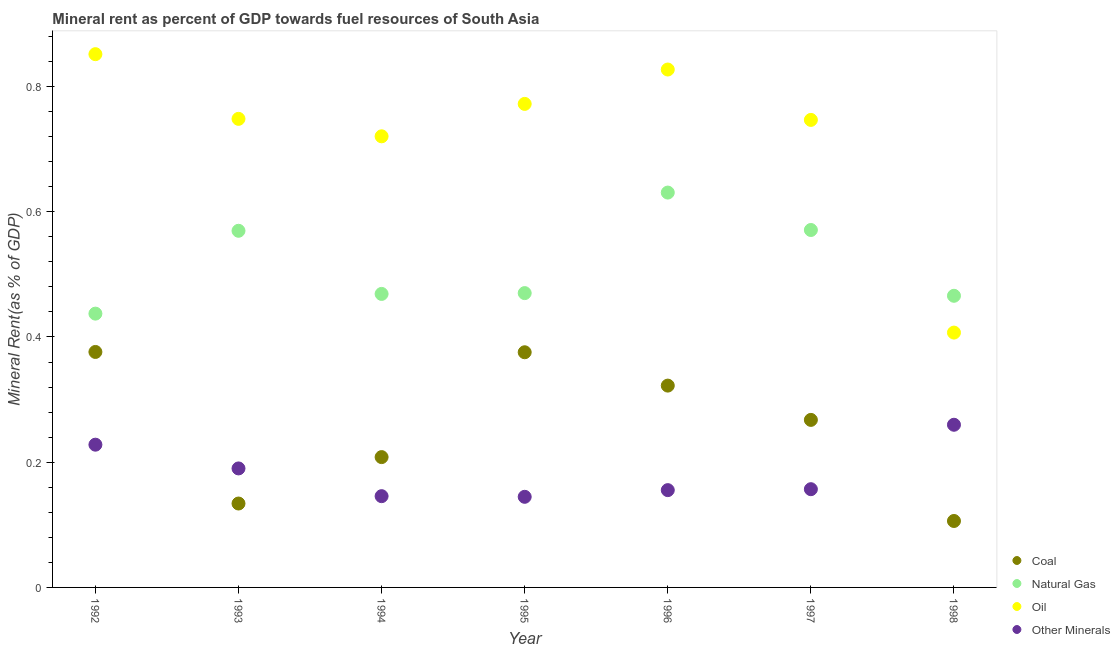What is the  rent of other minerals in 1996?
Ensure brevity in your answer.  0.16. Across all years, what is the maximum  rent of other minerals?
Provide a short and direct response. 0.26. Across all years, what is the minimum oil rent?
Your response must be concise. 0.41. In which year was the  rent of other minerals minimum?
Give a very brief answer. 1995. What is the total natural gas rent in the graph?
Offer a very short reply. 3.61. What is the difference between the coal rent in 1994 and that in 1996?
Offer a terse response. -0.11. What is the difference between the oil rent in 1994 and the coal rent in 1995?
Keep it short and to the point. 0.34. What is the average natural gas rent per year?
Give a very brief answer. 0.52. In the year 1992, what is the difference between the natural gas rent and  rent of other minerals?
Give a very brief answer. 0.21. In how many years, is the  rent of other minerals greater than 0.7600000000000001 %?
Give a very brief answer. 0. What is the ratio of the coal rent in 1993 to that in 1994?
Give a very brief answer. 0.64. Is the oil rent in 1997 less than that in 1998?
Keep it short and to the point. No. What is the difference between the highest and the second highest natural gas rent?
Provide a short and direct response. 0.06. What is the difference between the highest and the lowest  rent of other minerals?
Make the answer very short. 0.12. In how many years, is the coal rent greater than the average coal rent taken over all years?
Provide a short and direct response. 4. Is it the case that in every year, the sum of the coal rent and natural gas rent is greater than the oil rent?
Your response must be concise. No. How many years are there in the graph?
Your answer should be compact. 7. What is the difference between two consecutive major ticks on the Y-axis?
Your answer should be compact. 0.2. Does the graph contain grids?
Keep it short and to the point. No. How many legend labels are there?
Your answer should be very brief. 4. How are the legend labels stacked?
Keep it short and to the point. Vertical. What is the title of the graph?
Offer a very short reply. Mineral rent as percent of GDP towards fuel resources of South Asia. What is the label or title of the Y-axis?
Your answer should be compact. Mineral Rent(as % of GDP). What is the Mineral Rent(as % of GDP) of Coal in 1992?
Your answer should be compact. 0.38. What is the Mineral Rent(as % of GDP) of Natural Gas in 1992?
Make the answer very short. 0.44. What is the Mineral Rent(as % of GDP) in Oil in 1992?
Offer a very short reply. 0.85. What is the Mineral Rent(as % of GDP) of Other Minerals in 1992?
Ensure brevity in your answer.  0.23. What is the Mineral Rent(as % of GDP) in Coal in 1993?
Your response must be concise. 0.13. What is the Mineral Rent(as % of GDP) in Natural Gas in 1993?
Your response must be concise. 0.57. What is the Mineral Rent(as % of GDP) of Oil in 1993?
Keep it short and to the point. 0.75. What is the Mineral Rent(as % of GDP) in Other Minerals in 1993?
Provide a short and direct response. 0.19. What is the Mineral Rent(as % of GDP) of Coal in 1994?
Keep it short and to the point. 0.21. What is the Mineral Rent(as % of GDP) of Natural Gas in 1994?
Give a very brief answer. 0.47. What is the Mineral Rent(as % of GDP) of Oil in 1994?
Make the answer very short. 0.72. What is the Mineral Rent(as % of GDP) of Other Minerals in 1994?
Your response must be concise. 0.15. What is the Mineral Rent(as % of GDP) in Coal in 1995?
Your response must be concise. 0.38. What is the Mineral Rent(as % of GDP) of Natural Gas in 1995?
Make the answer very short. 0.47. What is the Mineral Rent(as % of GDP) of Oil in 1995?
Give a very brief answer. 0.77. What is the Mineral Rent(as % of GDP) in Other Minerals in 1995?
Make the answer very short. 0.14. What is the Mineral Rent(as % of GDP) of Coal in 1996?
Provide a succinct answer. 0.32. What is the Mineral Rent(as % of GDP) in Natural Gas in 1996?
Give a very brief answer. 0.63. What is the Mineral Rent(as % of GDP) of Oil in 1996?
Give a very brief answer. 0.83. What is the Mineral Rent(as % of GDP) in Other Minerals in 1996?
Provide a succinct answer. 0.16. What is the Mineral Rent(as % of GDP) in Coal in 1997?
Offer a terse response. 0.27. What is the Mineral Rent(as % of GDP) of Natural Gas in 1997?
Your response must be concise. 0.57. What is the Mineral Rent(as % of GDP) of Oil in 1997?
Keep it short and to the point. 0.75. What is the Mineral Rent(as % of GDP) of Other Minerals in 1997?
Your answer should be very brief. 0.16. What is the Mineral Rent(as % of GDP) in Coal in 1998?
Give a very brief answer. 0.11. What is the Mineral Rent(as % of GDP) in Natural Gas in 1998?
Provide a short and direct response. 0.47. What is the Mineral Rent(as % of GDP) in Oil in 1998?
Provide a succinct answer. 0.41. What is the Mineral Rent(as % of GDP) in Other Minerals in 1998?
Ensure brevity in your answer.  0.26. Across all years, what is the maximum Mineral Rent(as % of GDP) in Coal?
Provide a short and direct response. 0.38. Across all years, what is the maximum Mineral Rent(as % of GDP) in Natural Gas?
Provide a short and direct response. 0.63. Across all years, what is the maximum Mineral Rent(as % of GDP) in Oil?
Offer a very short reply. 0.85. Across all years, what is the maximum Mineral Rent(as % of GDP) in Other Minerals?
Your answer should be compact. 0.26. Across all years, what is the minimum Mineral Rent(as % of GDP) of Coal?
Your answer should be very brief. 0.11. Across all years, what is the minimum Mineral Rent(as % of GDP) in Natural Gas?
Keep it short and to the point. 0.44. Across all years, what is the minimum Mineral Rent(as % of GDP) of Oil?
Ensure brevity in your answer.  0.41. Across all years, what is the minimum Mineral Rent(as % of GDP) in Other Minerals?
Make the answer very short. 0.14. What is the total Mineral Rent(as % of GDP) in Coal in the graph?
Offer a terse response. 1.79. What is the total Mineral Rent(as % of GDP) of Natural Gas in the graph?
Your answer should be very brief. 3.61. What is the total Mineral Rent(as % of GDP) in Oil in the graph?
Provide a succinct answer. 5.07. What is the total Mineral Rent(as % of GDP) in Other Minerals in the graph?
Ensure brevity in your answer.  1.28. What is the difference between the Mineral Rent(as % of GDP) of Coal in 1992 and that in 1993?
Make the answer very short. 0.24. What is the difference between the Mineral Rent(as % of GDP) of Natural Gas in 1992 and that in 1993?
Your response must be concise. -0.13. What is the difference between the Mineral Rent(as % of GDP) in Oil in 1992 and that in 1993?
Give a very brief answer. 0.1. What is the difference between the Mineral Rent(as % of GDP) of Other Minerals in 1992 and that in 1993?
Your response must be concise. 0.04. What is the difference between the Mineral Rent(as % of GDP) in Coal in 1992 and that in 1994?
Your answer should be very brief. 0.17. What is the difference between the Mineral Rent(as % of GDP) of Natural Gas in 1992 and that in 1994?
Your answer should be very brief. -0.03. What is the difference between the Mineral Rent(as % of GDP) of Oil in 1992 and that in 1994?
Keep it short and to the point. 0.13. What is the difference between the Mineral Rent(as % of GDP) of Other Minerals in 1992 and that in 1994?
Provide a short and direct response. 0.08. What is the difference between the Mineral Rent(as % of GDP) in Coal in 1992 and that in 1995?
Offer a terse response. 0. What is the difference between the Mineral Rent(as % of GDP) in Natural Gas in 1992 and that in 1995?
Your answer should be very brief. -0.03. What is the difference between the Mineral Rent(as % of GDP) of Oil in 1992 and that in 1995?
Offer a very short reply. 0.08. What is the difference between the Mineral Rent(as % of GDP) of Other Minerals in 1992 and that in 1995?
Keep it short and to the point. 0.08. What is the difference between the Mineral Rent(as % of GDP) in Coal in 1992 and that in 1996?
Offer a terse response. 0.05. What is the difference between the Mineral Rent(as % of GDP) of Natural Gas in 1992 and that in 1996?
Offer a terse response. -0.19. What is the difference between the Mineral Rent(as % of GDP) in Oil in 1992 and that in 1996?
Offer a terse response. 0.02. What is the difference between the Mineral Rent(as % of GDP) in Other Minerals in 1992 and that in 1996?
Your response must be concise. 0.07. What is the difference between the Mineral Rent(as % of GDP) of Coal in 1992 and that in 1997?
Provide a short and direct response. 0.11. What is the difference between the Mineral Rent(as % of GDP) of Natural Gas in 1992 and that in 1997?
Provide a succinct answer. -0.13. What is the difference between the Mineral Rent(as % of GDP) of Oil in 1992 and that in 1997?
Provide a succinct answer. 0.1. What is the difference between the Mineral Rent(as % of GDP) of Other Minerals in 1992 and that in 1997?
Your response must be concise. 0.07. What is the difference between the Mineral Rent(as % of GDP) in Coal in 1992 and that in 1998?
Your answer should be very brief. 0.27. What is the difference between the Mineral Rent(as % of GDP) in Natural Gas in 1992 and that in 1998?
Provide a succinct answer. -0.03. What is the difference between the Mineral Rent(as % of GDP) of Oil in 1992 and that in 1998?
Keep it short and to the point. 0.44. What is the difference between the Mineral Rent(as % of GDP) in Other Minerals in 1992 and that in 1998?
Offer a very short reply. -0.03. What is the difference between the Mineral Rent(as % of GDP) in Coal in 1993 and that in 1994?
Your answer should be very brief. -0.07. What is the difference between the Mineral Rent(as % of GDP) in Natural Gas in 1993 and that in 1994?
Give a very brief answer. 0.1. What is the difference between the Mineral Rent(as % of GDP) of Oil in 1993 and that in 1994?
Offer a very short reply. 0.03. What is the difference between the Mineral Rent(as % of GDP) of Other Minerals in 1993 and that in 1994?
Give a very brief answer. 0.04. What is the difference between the Mineral Rent(as % of GDP) of Coal in 1993 and that in 1995?
Your answer should be very brief. -0.24. What is the difference between the Mineral Rent(as % of GDP) of Natural Gas in 1993 and that in 1995?
Offer a terse response. 0.1. What is the difference between the Mineral Rent(as % of GDP) in Oil in 1993 and that in 1995?
Offer a very short reply. -0.02. What is the difference between the Mineral Rent(as % of GDP) of Other Minerals in 1993 and that in 1995?
Offer a terse response. 0.05. What is the difference between the Mineral Rent(as % of GDP) of Coal in 1993 and that in 1996?
Provide a succinct answer. -0.19. What is the difference between the Mineral Rent(as % of GDP) of Natural Gas in 1993 and that in 1996?
Offer a terse response. -0.06. What is the difference between the Mineral Rent(as % of GDP) of Oil in 1993 and that in 1996?
Keep it short and to the point. -0.08. What is the difference between the Mineral Rent(as % of GDP) in Other Minerals in 1993 and that in 1996?
Keep it short and to the point. 0.03. What is the difference between the Mineral Rent(as % of GDP) in Coal in 1993 and that in 1997?
Provide a short and direct response. -0.13. What is the difference between the Mineral Rent(as % of GDP) of Natural Gas in 1993 and that in 1997?
Keep it short and to the point. -0. What is the difference between the Mineral Rent(as % of GDP) in Oil in 1993 and that in 1997?
Provide a succinct answer. 0. What is the difference between the Mineral Rent(as % of GDP) in Other Minerals in 1993 and that in 1997?
Offer a terse response. 0.03. What is the difference between the Mineral Rent(as % of GDP) of Coal in 1993 and that in 1998?
Your answer should be very brief. 0.03. What is the difference between the Mineral Rent(as % of GDP) of Natural Gas in 1993 and that in 1998?
Offer a terse response. 0.1. What is the difference between the Mineral Rent(as % of GDP) in Oil in 1993 and that in 1998?
Your answer should be compact. 0.34. What is the difference between the Mineral Rent(as % of GDP) of Other Minerals in 1993 and that in 1998?
Provide a short and direct response. -0.07. What is the difference between the Mineral Rent(as % of GDP) in Coal in 1994 and that in 1995?
Your answer should be very brief. -0.17. What is the difference between the Mineral Rent(as % of GDP) in Natural Gas in 1994 and that in 1995?
Ensure brevity in your answer.  -0. What is the difference between the Mineral Rent(as % of GDP) of Oil in 1994 and that in 1995?
Provide a short and direct response. -0.05. What is the difference between the Mineral Rent(as % of GDP) in Coal in 1994 and that in 1996?
Your answer should be very brief. -0.11. What is the difference between the Mineral Rent(as % of GDP) of Natural Gas in 1994 and that in 1996?
Ensure brevity in your answer.  -0.16. What is the difference between the Mineral Rent(as % of GDP) of Oil in 1994 and that in 1996?
Your answer should be very brief. -0.11. What is the difference between the Mineral Rent(as % of GDP) in Other Minerals in 1994 and that in 1996?
Your response must be concise. -0.01. What is the difference between the Mineral Rent(as % of GDP) in Coal in 1994 and that in 1997?
Make the answer very short. -0.06. What is the difference between the Mineral Rent(as % of GDP) of Natural Gas in 1994 and that in 1997?
Your answer should be compact. -0.1. What is the difference between the Mineral Rent(as % of GDP) of Oil in 1994 and that in 1997?
Provide a short and direct response. -0.03. What is the difference between the Mineral Rent(as % of GDP) in Other Minerals in 1994 and that in 1997?
Make the answer very short. -0.01. What is the difference between the Mineral Rent(as % of GDP) of Coal in 1994 and that in 1998?
Provide a short and direct response. 0.1. What is the difference between the Mineral Rent(as % of GDP) of Natural Gas in 1994 and that in 1998?
Give a very brief answer. 0. What is the difference between the Mineral Rent(as % of GDP) of Oil in 1994 and that in 1998?
Make the answer very short. 0.31. What is the difference between the Mineral Rent(as % of GDP) of Other Minerals in 1994 and that in 1998?
Offer a very short reply. -0.11. What is the difference between the Mineral Rent(as % of GDP) in Coal in 1995 and that in 1996?
Your answer should be very brief. 0.05. What is the difference between the Mineral Rent(as % of GDP) of Natural Gas in 1995 and that in 1996?
Give a very brief answer. -0.16. What is the difference between the Mineral Rent(as % of GDP) of Oil in 1995 and that in 1996?
Provide a short and direct response. -0.05. What is the difference between the Mineral Rent(as % of GDP) in Other Minerals in 1995 and that in 1996?
Offer a terse response. -0.01. What is the difference between the Mineral Rent(as % of GDP) of Coal in 1995 and that in 1997?
Make the answer very short. 0.11. What is the difference between the Mineral Rent(as % of GDP) of Natural Gas in 1995 and that in 1997?
Your response must be concise. -0.1. What is the difference between the Mineral Rent(as % of GDP) of Oil in 1995 and that in 1997?
Provide a short and direct response. 0.03. What is the difference between the Mineral Rent(as % of GDP) in Other Minerals in 1995 and that in 1997?
Make the answer very short. -0.01. What is the difference between the Mineral Rent(as % of GDP) in Coal in 1995 and that in 1998?
Your answer should be very brief. 0.27. What is the difference between the Mineral Rent(as % of GDP) in Natural Gas in 1995 and that in 1998?
Your answer should be very brief. 0. What is the difference between the Mineral Rent(as % of GDP) of Oil in 1995 and that in 1998?
Keep it short and to the point. 0.37. What is the difference between the Mineral Rent(as % of GDP) of Other Minerals in 1995 and that in 1998?
Provide a short and direct response. -0.12. What is the difference between the Mineral Rent(as % of GDP) in Coal in 1996 and that in 1997?
Make the answer very short. 0.05. What is the difference between the Mineral Rent(as % of GDP) of Natural Gas in 1996 and that in 1997?
Provide a short and direct response. 0.06. What is the difference between the Mineral Rent(as % of GDP) of Oil in 1996 and that in 1997?
Offer a terse response. 0.08. What is the difference between the Mineral Rent(as % of GDP) in Other Minerals in 1996 and that in 1997?
Keep it short and to the point. -0. What is the difference between the Mineral Rent(as % of GDP) in Coal in 1996 and that in 1998?
Keep it short and to the point. 0.22. What is the difference between the Mineral Rent(as % of GDP) of Natural Gas in 1996 and that in 1998?
Offer a very short reply. 0.16. What is the difference between the Mineral Rent(as % of GDP) in Oil in 1996 and that in 1998?
Provide a short and direct response. 0.42. What is the difference between the Mineral Rent(as % of GDP) in Other Minerals in 1996 and that in 1998?
Make the answer very short. -0.1. What is the difference between the Mineral Rent(as % of GDP) of Coal in 1997 and that in 1998?
Your answer should be compact. 0.16. What is the difference between the Mineral Rent(as % of GDP) in Natural Gas in 1997 and that in 1998?
Your answer should be compact. 0.11. What is the difference between the Mineral Rent(as % of GDP) in Oil in 1997 and that in 1998?
Keep it short and to the point. 0.34. What is the difference between the Mineral Rent(as % of GDP) in Other Minerals in 1997 and that in 1998?
Give a very brief answer. -0.1. What is the difference between the Mineral Rent(as % of GDP) in Coal in 1992 and the Mineral Rent(as % of GDP) in Natural Gas in 1993?
Make the answer very short. -0.19. What is the difference between the Mineral Rent(as % of GDP) in Coal in 1992 and the Mineral Rent(as % of GDP) in Oil in 1993?
Give a very brief answer. -0.37. What is the difference between the Mineral Rent(as % of GDP) of Coal in 1992 and the Mineral Rent(as % of GDP) of Other Minerals in 1993?
Provide a succinct answer. 0.19. What is the difference between the Mineral Rent(as % of GDP) in Natural Gas in 1992 and the Mineral Rent(as % of GDP) in Oil in 1993?
Make the answer very short. -0.31. What is the difference between the Mineral Rent(as % of GDP) of Natural Gas in 1992 and the Mineral Rent(as % of GDP) of Other Minerals in 1993?
Provide a short and direct response. 0.25. What is the difference between the Mineral Rent(as % of GDP) of Oil in 1992 and the Mineral Rent(as % of GDP) of Other Minerals in 1993?
Provide a succinct answer. 0.66. What is the difference between the Mineral Rent(as % of GDP) in Coal in 1992 and the Mineral Rent(as % of GDP) in Natural Gas in 1994?
Keep it short and to the point. -0.09. What is the difference between the Mineral Rent(as % of GDP) in Coal in 1992 and the Mineral Rent(as % of GDP) in Oil in 1994?
Your response must be concise. -0.34. What is the difference between the Mineral Rent(as % of GDP) of Coal in 1992 and the Mineral Rent(as % of GDP) of Other Minerals in 1994?
Provide a succinct answer. 0.23. What is the difference between the Mineral Rent(as % of GDP) in Natural Gas in 1992 and the Mineral Rent(as % of GDP) in Oil in 1994?
Your answer should be very brief. -0.28. What is the difference between the Mineral Rent(as % of GDP) of Natural Gas in 1992 and the Mineral Rent(as % of GDP) of Other Minerals in 1994?
Provide a succinct answer. 0.29. What is the difference between the Mineral Rent(as % of GDP) in Oil in 1992 and the Mineral Rent(as % of GDP) in Other Minerals in 1994?
Provide a succinct answer. 0.71. What is the difference between the Mineral Rent(as % of GDP) of Coal in 1992 and the Mineral Rent(as % of GDP) of Natural Gas in 1995?
Offer a terse response. -0.09. What is the difference between the Mineral Rent(as % of GDP) in Coal in 1992 and the Mineral Rent(as % of GDP) in Oil in 1995?
Provide a short and direct response. -0.4. What is the difference between the Mineral Rent(as % of GDP) in Coal in 1992 and the Mineral Rent(as % of GDP) in Other Minerals in 1995?
Ensure brevity in your answer.  0.23. What is the difference between the Mineral Rent(as % of GDP) of Natural Gas in 1992 and the Mineral Rent(as % of GDP) of Oil in 1995?
Offer a terse response. -0.33. What is the difference between the Mineral Rent(as % of GDP) of Natural Gas in 1992 and the Mineral Rent(as % of GDP) of Other Minerals in 1995?
Provide a succinct answer. 0.29. What is the difference between the Mineral Rent(as % of GDP) in Oil in 1992 and the Mineral Rent(as % of GDP) in Other Minerals in 1995?
Your answer should be very brief. 0.71. What is the difference between the Mineral Rent(as % of GDP) in Coal in 1992 and the Mineral Rent(as % of GDP) in Natural Gas in 1996?
Ensure brevity in your answer.  -0.25. What is the difference between the Mineral Rent(as % of GDP) in Coal in 1992 and the Mineral Rent(as % of GDP) in Oil in 1996?
Offer a very short reply. -0.45. What is the difference between the Mineral Rent(as % of GDP) in Coal in 1992 and the Mineral Rent(as % of GDP) in Other Minerals in 1996?
Ensure brevity in your answer.  0.22. What is the difference between the Mineral Rent(as % of GDP) of Natural Gas in 1992 and the Mineral Rent(as % of GDP) of Oil in 1996?
Provide a short and direct response. -0.39. What is the difference between the Mineral Rent(as % of GDP) in Natural Gas in 1992 and the Mineral Rent(as % of GDP) in Other Minerals in 1996?
Your answer should be very brief. 0.28. What is the difference between the Mineral Rent(as % of GDP) of Oil in 1992 and the Mineral Rent(as % of GDP) of Other Minerals in 1996?
Provide a succinct answer. 0.7. What is the difference between the Mineral Rent(as % of GDP) in Coal in 1992 and the Mineral Rent(as % of GDP) in Natural Gas in 1997?
Offer a very short reply. -0.19. What is the difference between the Mineral Rent(as % of GDP) in Coal in 1992 and the Mineral Rent(as % of GDP) in Oil in 1997?
Make the answer very short. -0.37. What is the difference between the Mineral Rent(as % of GDP) in Coal in 1992 and the Mineral Rent(as % of GDP) in Other Minerals in 1997?
Provide a succinct answer. 0.22. What is the difference between the Mineral Rent(as % of GDP) of Natural Gas in 1992 and the Mineral Rent(as % of GDP) of Oil in 1997?
Your answer should be compact. -0.31. What is the difference between the Mineral Rent(as % of GDP) of Natural Gas in 1992 and the Mineral Rent(as % of GDP) of Other Minerals in 1997?
Your response must be concise. 0.28. What is the difference between the Mineral Rent(as % of GDP) in Oil in 1992 and the Mineral Rent(as % of GDP) in Other Minerals in 1997?
Provide a short and direct response. 0.69. What is the difference between the Mineral Rent(as % of GDP) in Coal in 1992 and the Mineral Rent(as % of GDP) in Natural Gas in 1998?
Offer a terse response. -0.09. What is the difference between the Mineral Rent(as % of GDP) of Coal in 1992 and the Mineral Rent(as % of GDP) of Oil in 1998?
Provide a short and direct response. -0.03. What is the difference between the Mineral Rent(as % of GDP) of Coal in 1992 and the Mineral Rent(as % of GDP) of Other Minerals in 1998?
Keep it short and to the point. 0.12. What is the difference between the Mineral Rent(as % of GDP) of Natural Gas in 1992 and the Mineral Rent(as % of GDP) of Oil in 1998?
Your answer should be compact. 0.03. What is the difference between the Mineral Rent(as % of GDP) in Natural Gas in 1992 and the Mineral Rent(as % of GDP) in Other Minerals in 1998?
Your response must be concise. 0.18. What is the difference between the Mineral Rent(as % of GDP) of Oil in 1992 and the Mineral Rent(as % of GDP) of Other Minerals in 1998?
Give a very brief answer. 0.59. What is the difference between the Mineral Rent(as % of GDP) in Coal in 1993 and the Mineral Rent(as % of GDP) in Natural Gas in 1994?
Make the answer very short. -0.33. What is the difference between the Mineral Rent(as % of GDP) in Coal in 1993 and the Mineral Rent(as % of GDP) in Oil in 1994?
Your answer should be very brief. -0.59. What is the difference between the Mineral Rent(as % of GDP) of Coal in 1993 and the Mineral Rent(as % of GDP) of Other Minerals in 1994?
Keep it short and to the point. -0.01. What is the difference between the Mineral Rent(as % of GDP) of Natural Gas in 1993 and the Mineral Rent(as % of GDP) of Oil in 1994?
Ensure brevity in your answer.  -0.15. What is the difference between the Mineral Rent(as % of GDP) in Natural Gas in 1993 and the Mineral Rent(as % of GDP) in Other Minerals in 1994?
Make the answer very short. 0.42. What is the difference between the Mineral Rent(as % of GDP) in Oil in 1993 and the Mineral Rent(as % of GDP) in Other Minerals in 1994?
Your response must be concise. 0.6. What is the difference between the Mineral Rent(as % of GDP) in Coal in 1993 and the Mineral Rent(as % of GDP) in Natural Gas in 1995?
Give a very brief answer. -0.34. What is the difference between the Mineral Rent(as % of GDP) of Coal in 1993 and the Mineral Rent(as % of GDP) of Oil in 1995?
Provide a succinct answer. -0.64. What is the difference between the Mineral Rent(as % of GDP) of Coal in 1993 and the Mineral Rent(as % of GDP) of Other Minerals in 1995?
Your answer should be compact. -0.01. What is the difference between the Mineral Rent(as % of GDP) in Natural Gas in 1993 and the Mineral Rent(as % of GDP) in Oil in 1995?
Offer a terse response. -0.2. What is the difference between the Mineral Rent(as % of GDP) in Natural Gas in 1993 and the Mineral Rent(as % of GDP) in Other Minerals in 1995?
Your answer should be very brief. 0.42. What is the difference between the Mineral Rent(as % of GDP) in Oil in 1993 and the Mineral Rent(as % of GDP) in Other Minerals in 1995?
Your answer should be compact. 0.6. What is the difference between the Mineral Rent(as % of GDP) in Coal in 1993 and the Mineral Rent(as % of GDP) in Natural Gas in 1996?
Give a very brief answer. -0.5. What is the difference between the Mineral Rent(as % of GDP) in Coal in 1993 and the Mineral Rent(as % of GDP) in Oil in 1996?
Your answer should be very brief. -0.69. What is the difference between the Mineral Rent(as % of GDP) of Coal in 1993 and the Mineral Rent(as % of GDP) of Other Minerals in 1996?
Your answer should be very brief. -0.02. What is the difference between the Mineral Rent(as % of GDP) of Natural Gas in 1993 and the Mineral Rent(as % of GDP) of Oil in 1996?
Your answer should be very brief. -0.26. What is the difference between the Mineral Rent(as % of GDP) in Natural Gas in 1993 and the Mineral Rent(as % of GDP) in Other Minerals in 1996?
Offer a terse response. 0.41. What is the difference between the Mineral Rent(as % of GDP) of Oil in 1993 and the Mineral Rent(as % of GDP) of Other Minerals in 1996?
Provide a succinct answer. 0.59. What is the difference between the Mineral Rent(as % of GDP) of Coal in 1993 and the Mineral Rent(as % of GDP) of Natural Gas in 1997?
Give a very brief answer. -0.44. What is the difference between the Mineral Rent(as % of GDP) of Coal in 1993 and the Mineral Rent(as % of GDP) of Oil in 1997?
Offer a terse response. -0.61. What is the difference between the Mineral Rent(as % of GDP) in Coal in 1993 and the Mineral Rent(as % of GDP) in Other Minerals in 1997?
Provide a short and direct response. -0.02. What is the difference between the Mineral Rent(as % of GDP) of Natural Gas in 1993 and the Mineral Rent(as % of GDP) of Oil in 1997?
Make the answer very short. -0.18. What is the difference between the Mineral Rent(as % of GDP) of Natural Gas in 1993 and the Mineral Rent(as % of GDP) of Other Minerals in 1997?
Keep it short and to the point. 0.41. What is the difference between the Mineral Rent(as % of GDP) in Oil in 1993 and the Mineral Rent(as % of GDP) in Other Minerals in 1997?
Provide a succinct answer. 0.59. What is the difference between the Mineral Rent(as % of GDP) in Coal in 1993 and the Mineral Rent(as % of GDP) in Natural Gas in 1998?
Keep it short and to the point. -0.33. What is the difference between the Mineral Rent(as % of GDP) of Coal in 1993 and the Mineral Rent(as % of GDP) of Oil in 1998?
Your answer should be very brief. -0.27. What is the difference between the Mineral Rent(as % of GDP) in Coal in 1993 and the Mineral Rent(as % of GDP) in Other Minerals in 1998?
Your answer should be compact. -0.13. What is the difference between the Mineral Rent(as % of GDP) of Natural Gas in 1993 and the Mineral Rent(as % of GDP) of Oil in 1998?
Provide a short and direct response. 0.16. What is the difference between the Mineral Rent(as % of GDP) in Natural Gas in 1993 and the Mineral Rent(as % of GDP) in Other Minerals in 1998?
Offer a terse response. 0.31. What is the difference between the Mineral Rent(as % of GDP) of Oil in 1993 and the Mineral Rent(as % of GDP) of Other Minerals in 1998?
Make the answer very short. 0.49. What is the difference between the Mineral Rent(as % of GDP) in Coal in 1994 and the Mineral Rent(as % of GDP) in Natural Gas in 1995?
Give a very brief answer. -0.26. What is the difference between the Mineral Rent(as % of GDP) of Coal in 1994 and the Mineral Rent(as % of GDP) of Oil in 1995?
Give a very brief answer. -0.56. What is the difference between the Mineral Rent(as % of GDP) in Coal in 1994 and the Mineral Rent(as % of GDP) in Other Minerals in 1995?
Provide a succinct answer. 0.06. What is the difference between the Mineral Rent(as % of GDP) in Natural Gas in 1994 and the Mineral Rent(as % of GDP) in Oil in 1995?
Keep it short and to the point. -0.3. What is the difference between the Mineral Rent(as % of GDP) of Natural Gas in 1994 and the Mineral Rent(as % of GDP) of Other Minerals in 1995?
Your response must be concise. 0.32. What is the difference between the Mineral Rent(as % of GDP) of Oil in 1994 and the Mineral Rent(as % of GDP) of Other Minerals in 1995?
Your answer should be compact. 0.58. What is the difference between the Mineral Rent(as % of GDP) of Coal in 1994 and the Mineral Rent(as % of GDP) of Natural Gas in 1996?
Give a very brief answer. -0.42. What is the difference between the Mineral Rent(as % of GDP) in Coal in 1994 and the Mineral Rent(as % of GDP) in Oil in 1996?
Your answer should be compact. -0.62. What is the difference between the Mineral Rent(as % of GDP) in Coal in 1994 and the Mineral Rent(as % of GDP) in Other Minerals in 1996?
Your response must be concise. 0.05. What is the difference between the Mineral Rent(as % of GDP) in Natural Gas in 1994 and the Mineral Rent(as % of GDP) in Oil in 1996?
Provide a short and direct response. -0.36. What is the difference between the Mineral Rent(as % of GDP) of Natural Gas in 1994 and the Mineral Rent(as % of GDP) of Other Minerals in 1996?
Keep it short and to the point. 0.31. What is the difference between the Mineral Rent(as % of GDP) in Oil in 1994 and the Mineral Rent(as % of GDP) in Other Minerals in 1996?
Your response must be concise. 0.57. What is the difference between the Mineral Rent(as % of GDP) of Coal in 1994 and the Mineral Rent(as % of GDP) of Natural Gas in 1997?
Provide a short and direct response. -0.36. What is the difference between the Mineral Rent(as % of GDP) in Coal in 1994 and the Mineral Rent(as % of GDP) in Oil in 1997?
Ensure brevity in your answer.  -0.54. What is the difference between the Mineral Rent(as % of GDP) of Coal in 1994 and the Mineral Rent(as % of GDP) of Other Minerals in 1997?
Make the answer very short. 0.05. What is the difference between the Mineral Rent(as % of GDP) in Natural Gas in 1994 and the Mineral Rent(as % of GDP) in Oil in 1997?
Ensure brevity in your answer.  -0.28. What is the difference between the Mineral Rent(as % of GDP) in Natural Gas in 1994 and the Mineral Rent(as % of GDP) in Other Minerals in 1997?
Provide a succinct answer. 0.31. What is the difference between the Mineral Rent(as % of GDP) in Oil in 1994 and the Mineral Rent(as % of GDP) in Other Minerals in 1997?
Your answer should be very brief. 0.56. What is the difference between the Mineral Rent(as % of GDP) of Coal in 1994 and the Mineral Rent(as % of GDP) of Natural Gas in 1998?
Ensure brevity in your answer.  -0.26. What is the difference between the Mineral Rent(as % of GDP) in Coal in 1994 and the Mineral Rent(as % of GDP) in Oil in 1998?
Keep it short and to the point. -0.2. What is the difference between the Mineral Rent(as % of GDP) of Coal in 1994 and the Mineral Rent(as % of GDP) of Other Minerals in 1998?
Your answer should be very brief. -0.05. What is the difference between the Mineral Rent(as % of GDP) of Natural Gas in 1994 and the Mineral Rent(as % of GDP) of Oil in 1998?
Provide a succinct answer. 0.06. What is the difference between the Mineral Rent(as % of GDP) in Natural Gas in 1994 and the Mineral Rent(as % of GDP) in Other Minerals in 1998?
Offer a very short reply. 0.21. What is the difference between the Mineral Rent(as % of GDP) of Oil in 1994 and the Mineral Rent(as % of GDP) of Other Minerals in 1998?
Your answer should be compact. 0.46. What is the difference between the Mineral Rent(as % of GDP) of Coal in 1995 and the Mineral Rent(as % of GDP) of Natural Gas in 1996?
Offer a terse response. -0.26. What is the difference between the Mineral Rent(as % of GDP) in Coal in 1995 and the Mineral Rent(as % of GDP) in Oil in 1996?
Offer a very short reply. -0.45. What is the difference between the Mineral Rent(as % of GDP) in Coal in 1995 and the Mineral Rent(as % of GDP) in Other Minerals in 1996?
Provide a short and direct response. 0.22. What is the difference between the Mineral Rent(as % of GDP) of Natural Gas in 1995 and the Mineral Rent(as % of GDP) of Oil in 1996?
Ensure brevity in your answer.  -0.36. What is the difference between the Mineral Rent(as % of GDP) of Natural Gas in 1995 and the Mineral Rent(as % of GDP) of Other Minerals in 1996?
Offer a very short reply. 0.31. What is the difference between the Mineral Rent(as % of GDP) of Oil in 1995 and the Mineral Rent(as % of GDP) of Other Minerals in 1996?
Keep it short and to the point. 0.62. What is the difference between the Mineral Rent(as % of GDP) in Coal in 1995 and the Mineral Rent(as % of GDP) in Natural Gas in 1997?
Your answer should be compact. -0.2. What is the difference between the Mineral Rent(as % of GDP) of Coal in 1995 and the Mineral Rent(as % of GDP) of Oil in 1997?
Your answer should be compact. -0.37. What is the difference between the Mineral Rent(as % of GDP) in Coal in 1995 and the Mineral Rent(as % of GDP) in Other Minerals in 1997?
Make the answer very short. 0.22. What is the difference between the Mineral Rent(as % of GDP) of Natural Gas in 1995 and the Mineral Rent(as % of GDP) of Oil in 1997?
Provide a short and direct response. -0.28. What is the difference between the Mineral Rent(as % of GDP) in Natural Gas in 1995 and the Mineral Rent(as % of GDP) in Other Minerals in 1997?
Give a very brief answer. 0.31. What is the difference between the Mineral Rent(as % of GDP) of Oil in 1995 and the Mineral Rent(as % of GDP) of Other Minerals in 1997?
Keep it short and to the point. 0.62. What is the difference between the Mineral Rent(as % of GDP) of Coal in 1995 and the Mineral Rent(as % of GDP) of Natural Gas in 1998?
Provide a succinct answer. -0.09. What is the difference between the Mineral Rent(as % of GDP) in Coal in 1995 and the Mineral Rent(as % of GDP) in Oil in 1998?
Give a very brief answer. -0.03. What is the difference between the Mineral Rent(as % of GDP) of Coal in 1995 and the Mineral Rent(as % of GDP) of Other Minerals in 1998?
Your answer should be very brief. 0.12. What is the difference between the Mineral Rent(as % of GDP) in Natural Gas in 1995 and the Mineral Rent(as % of GDP) in Oil in 1998?
Provide a succinct answer. 0.06. What is the difference between the Mineral Rent(as % of GDP) in Natural Gas in 1995 and the Mineral Rent(as % of GDP) in Other Minerals in 1998?
Keep it short and to the point. 0.21. What is the difference between the Mineral Rent(as % of GDP) of Oil in 1995 and the Mineral Rent(as % of GDP) of Other Minerals in 1998?
Give a very brief answer. 0.51. What is the difference between the Mineral Rent(as % of GDP) of Coal in 1996 and the Mineral Rent(as % of GDP) of Natural Gas in 1997?
Offer a very short reply. -0.25. What is the difference between the Mineral Rent(as % of GDP) of Coal in 1996 and the Mineral Rent(as % of GDP) of Oil in 1997?
Your response must be concise. -0.42. What is the difference between the Mineral Rent(as % of GDP) in Coal in 1996 and the Mineral Rent(as % of GDP) in Other Minerals in 1997?
Your response must be concise. 0.17. What is the difference between the Mineral Rent(as % of GDP) of Natural Gas in 1996 and the Mineral Rent(as % of GDP) of Oil in 1997?
Offer a very short reply. -0.12. What is the difference between the Mineral Rent(as % of GDP) in Natural Gas in 1996 and the Mineral Rent(as % of GDP) in Other Minerals in 1997?
Make the answer very short. 0.47. What is the difference between the Mineral Rent(as % of GDP) of Oil in 1996 and the Mineral Rent(as % of GDP) of Other Minerals in 1997?
Offer a terse response. 0.67. What is the difference between the Mineral Rent(as % of GDP) in Coal in 1996 and the Mineral Rent(as % of GDP) in Natural Gas in 1998?
Ensure brevity in your answer.  -0.14. What is the difference between the Mineral Rent(as % of GDP) of Coal in 1996 and the Mineral Rent(as % of GDP) of Oil in 1998?
Keep it short and to the point. -0.08. What is the difference between the Mineral Rent(as % of GDP) of Coal in 1996 and the Mineral Rent(as % of GDP) of Other Minerals in 1998?
Make the answer very short. 0.06. What is the difference between the Mineral Rent(as % of GDP) in Natural Gas in 1996 and the Mineral Rent(as % of GDP) in Oil in 1998?
Your answer should be compact. 0.22. What is the difference between the Mineral Rent(as % of GDP) in Natural Gas in 1996 and the Mineral Rent(as % of GDP) in Other Minerals in 1998?
Keep it short and to the point. 0.37. What is the difference between the Mineral Rent(as % of GDP) of Oil in 1996 and the Mineral Rent(as % of GDP) of Other Minerals in 1998?
Ensure brevity in your answer.  0.57. What is the difference between the Mineral Rent(as % of GDP) in Coal in 1997 and the Mineral Rent(as % of GDP) in Natural Gas in 1998?
Ensure brevity in your answer.  -0.2. What is the difference between the Mineral Rent(as % of GDP) of Coal in 1997 and the Mineral Rent(as % of GDP) of Oil in 1998?
Make the answer very short. -0.14. What is the difference between the Mineral Rent(as % of GDP) in Coal in 1997 and the Mineral Rent(as % of GDP) in Other Minerals in 1998?
Offer a very short reply. 0.01. What is the difference between the Mineral Rent(as % of GDP) in Natural Gas in 1997 and the Mineral Rent(as % of GDP) in Oil in 1998?
Offer a very short reply. 0.16. What is the difference between the Mineral Rent(as % of GDP) in Natural Gas in 1997 and the Mineral Rent(as % of GDP) in Other Minerals in 1998?
Offer a very short reply. 0.31. What is the difference between the Mineral Rent(as % of GDP) of Oil in 1997 and the Mineral Rent(as % of GDP) of Other Minerals in 1998?
Ensure brevity in your answer.  0.49. What is the average Mineral Rent(as % of GDP) in Coal per year?
Your response must be concise. 0.26. What is the average Mineral Rent(as % of GDP) of Natural Gas per year?
Ensure brevity in your answer.  0.52. What is the average Mineral Rent(as % of GDP) in Oil per year?
Ensure brevity in your answer.  0.72. What is the average Mineral Rent(as % of GDP) of Other Minerals per year?
Offer a very short reply. 0.18. In the year 1992, what is the difference between the Mineral Rent(as % of GDP) of Coal and Mineral Rent(as % of GDP) of Natural Gas?
Offer a very short reply. -0.06. In the year 1992, what is the difference between the Mineral Rent(as % of GDP) of Coal and Mineral Rent(as % of GDP) of Oil?
Your answer should be very brief. -0.48. In the year 1992, what is the difference between the Mineral Rent(as % of GDP) in Coal and Mineral Rent(as % of GDP) in Other Minerals?
Make the answer very short. 0.15. In the year 1992, what is the difference between the Mineral Rent(as % of GDP) in Natural Gas and Mineral Rent(as % of GDP) in Oil?
Offer a very short reply. -0.41. In the year 1992, what is the difference between the Mineral Rent(as % of GDP) in Natural Gas and Mineral Rent(as % of GDP) in Other Minerals?
Offer a very short reply. 0.21. In the year 1992, what is the difference between the Mineral Rent(as % of GDP) of Oil and Mineral Rent(as % of GDP) of Other Minerals?
Your answer should be very brief. 0.62. In the year 1993, what is the difference between the Mineral Rent(as % of GDP) in Coal and Mineral Rent(as % of GDP) in Natural Gas?
Your answer should be compact. -0.44. In the year 1993, what is the difference between the Mineral Rent(as % of GDP) in Coal and Mineral Rent(as % of GDP) in Oil?
Offer a terse response. -0.61. In the year 1993, what is the difference between the Mineral Rent(as % of GDP) in Coal and Mineral Rent(as % of GDP) in Other Minerals?
Offer a terse response. -0.06. In the year 1993, what is the difference between the Mineral Rent(as % of GDP) of Natural Gas and Mineral Rent(as % of GDP) of Oil?
Ensure brevity in your answer.  -0.18. In the year 1993, what is the difference between the Mineral Rent(as % of GDP) of Natural Gas and Mineral Rent(as % of GDP) of Other Minerals?
Ensure brevity in your answer.  0.38. In the year 1993, what is the difference between the Mineral Rent(as % of GDP) of Oil and Mineral Rent(as % of GDP) of Other Minerals?
Your answer should be compact. 0.56. In the year 1994, what is the difference between the Mineral Rent(as % of GDP) of Coal and Mineral Rent(as % of GDP) of Natural Gas?
Your answer should be compact. -0.26. In the year 1994, what is the difference between the Mineral Rent(as % of GDP) of Coal and Mineral Rent(as % of GDP) of Oil?
Your response must be concise. -0.51. In the year 1994, what is the difference between the Mineral Rent(as % of GDP) in Coal and Mineral Rent(as % of GDP) in Other Minerals?
Your answer should be very brief. 0.06. In the year 1994, what is the difference between the Mineral Rent(as % of GDP) in Natural Gas and Mineral Rent(as % of GDP) in Oil?
Your response must be concise. -0.25. In the year 1994, what is the difference between the Mineral Rent(as % of GDP) in Natural Gas and Mineral Rent(as % of GDP) in Other Minerals?
Your answer should be very brief. 0.32. In the year 1994, what is the difference between the Mineral Rent(as % of GDP) in Oil and Mineral Rent(as % of GDP) in Other Minerals?
Provide a succinct answer. 0.57. In the year 1995, what is the difference between the Mineral Rent(as % of GDP) in Coal and Mineral Rent(as % of GDP) in Natural Gas?
Ensure brevity in your answer.  -0.09. In the year 1995, what is the difference between the Mineral Rent(as % of GDP) in Coal and Mineral Rent(as % of GDP) in Oil?
Your answer should be very brief. -0.4. In the year 1995, what is the difference between the Mineral Rent(as % of GDP) of Coal and Mineral Rent(as % of GDP) of Other Minerals?
Make the answer very short. 0.23. In the year 1995, what is the difference between the Mineral Rent(as % of GDP) of Natural Gas and Mineral Rent(as % of GDP) of Oil?
Keep it short and to the point. -0.3. In the year 1995, what is the difference between the Mineral Rent(as % of GDP) of Natural Gas and Mineral Rent(as % of GDP) of Other Minerals?
Give a very brief answer. 0.33. In the year 1995, what is the difference between the Mineral Rent(as % of GDP) in Oil and Mineral Rent(as % of GDP) in Other Minerals?
Offer a very short reply. 0.63. In the year 1996, what is the difference between the Mineral Rent(as % of GDP) of Coal and Mineral Rent(as % of GDP) of Natural Gas?
Your answer should be very brief. -0.31. In the year 1996, what is the difference between the Mineral Rent(as % of GDP) of Coal and Mineral Rent(as % of GDP) of Oil?
Provide a succinct answer. -0.5. In the year 1996, what is the difference between the Mineral Rent(as % of GDP) in Coal and Mineral Rent(as % of GDP) in Other Minerals?
Give a very brief answer. 0.17. In the year 1996, what is the difference between the Mineral Rent(as % of GDP) in Natural Gas and Mineral Rent(as % of GDP) in Oil?
Offer a very short reply. -0.2. In the year 1996, what is the difference between the Mineral Rent(as % of GDP) of Natural Gas and Mineral Rent(as % of GDP) of Other Minerals?
Provide a short and direct response. 0.48. In the year 1996, what is the difference between the Mineral Rent(as % of GDP) of Oil and Mineral Rent(as % of GDP) of Other Minerals?
Make the answer very short. 0.67. In the year 1997, what is the difference between the Mineral Rent(as % of GDP) in Coal and Mineral Rent(as % of GDP) in Natural Gas?
Provide a short and direct response. -0.3. In the year 1997, what is the difference between the Mineral Rent(as % of GDP) in Coal and Mineral Rent(as % of GDP) in Oil?
Make the answer very short. -0.48. In the year 1997, what is the difference between the Mineral Rent(as % of GDP) of Coal and Mineral Rent(as % of GDP) of Other Minerals?
Your answer should be compact. 0.11. In the year 1997, what is the difference between the Mineral Rent(as % of GDP) of Natural Gas and Mineral Rent(as % of GDP) of Oil?
Provide a succinct answer. -0.18. In the year 1997, what is the difference between the Mineral Rent(as % of GDP) in Natural Gas and Mineral Rent(as % of GDP) in Other Minerals?
Provide a short and direct response. 0.41. In the year 1997, what is the difference between the Mineral Rent(as % of GDP) in Oil and Mineral Rent(as % of GDP) in Other Minerals?
Provide a short and direct response. 0.59. In the year 1998, what is the difference between the Mineral Rent(as % of GDP) in Coal and Mineral Rent(as % of GDP) in Natural Gas?
Offer a very short reply. -0.36. In the year 1998, what is the difference between the Mineral Rent(as % of GDP) in Coal and Mineral Rent(as % of GDP) in Oil?
Provide a succinct answer. -0.3. In the year 1998, what is the difference between the Mineral Rent(as % of GDP) of Coal and Mineral Rent(as % of GDP) of Other Minerals?
Your answer should be compact. -0.15. In the year 1998, what is the difference between the Mineral Rent(as % of GDP) in Natural Gas and Mineral Rent(as % of GDP) in Oil?
Keep it short and to the point. 0.06. In the year 1998, what is the difference between the Mineral Rent(as % of GDP) of Natural Gas and Mineral Rent(as % of GDP) of Other Minerals?
Keep it short and to the point. 0.21. In the year 1998, what is the difference between the Mineral Rent(as % of GDP) of Oil and Mineral Rent(as % of GDP) of Other Minerals?
Your response must be concise. 0.15. What is the ratio of the Mineral Rent(as % of GDP) in Coal in 1992 to that in 1993?
Offer a terse response. 2.81. What is the ratio of the Mineral Rent(as % of GDP) in Natural Gas in 1992 to that in 1993?
Offer a very short reply. 0.77. What is the ratio of the Mineral Rent(as % of GDP) in Oil in 1992 to that in 1993?
Provide a short and direct response. 1.14. What is the ratio of the Mineral Rent(as % of GDP) in Other Minerals in 1992 to that in 1993?
Give a very brief answer. 1.2. What is the ratio of the Mineral Rent(as % of GDP) of Coal in 1992 to that in 1994?
Provide a short and direct response. 1.81. What is the ratio of the Mineral Rent(as % of GDP) in Natural Gas in 1992 to that in 1994?
Give a very brief answer. 0.93. What is the ratio of the Mineral Rent(as % of GDP) in Oil in 1992 to that in 1994?
Make the answer very short. 1.18. What is the ratio of the Mineral Rent(as % of GDP) in Other Minerals in 1992 to that in 1994?
Your answer should be very brief. 1.56. What is the ratio of the Mineral Rent(as % of GDP) in Coal in 1992 to that in 1995?
Make the answer very short. 1. What is the ratio of the Mineral Rent(as % of GDP) of Natural Gas in 1992 to that in 1995?
Offer a terse response. 0.93. What is the ratio of the Mineral Rent(as % of GDP) of Oil in 1992 to that in 1995?
Make the answer very short. 1.1. What is the ratio of the Mineral Rent(as % of GDP) in Other Minerals in 1992 to that in 1995?
Make the answer very short. 1.58. What is the ratio of the Mineral Rent(as % of GDP) of Natural Gas in 1992 to that in 1996?
Your answer should be compact. 0.69. What is the ratio of the Mineral Rent(as % of GDP) of Oil in 1992 to that in 1996?
Your answer should be compact. 1.03. What is the ratio of the Mineral Rent(as % of GDP) of Other Minerals in 1992 to that in 1996?
Keep it short and to the point. 1.47. What is the ratio of the Mineral Rent(as % of GDP) of Coal in 1992 to that in 1997?
Ensure brevity in your answer.  1.41. What is the ratio of the Mineral Rent(as % of GDP) of Natural Gas in 1992 to that in 1997?
Offer a very short reply. 0.77. What is the ratio of the Mineral Rent(as % of GDP) in Oil in 1992 to that in 1997?
Offer a terse response. 1.14. What is the ratio of the Mineral Rent(as % of GDP) of Other Minerals in 1992 to that in 1997?
Give a very brief answer. 1.45. What is the ratio of the Mineral Rent(as % of GDP) in Coal in 1992 to that in 1998?
Your answer should be very brief. 3.54. What is the ratio of the Mineral Rent(as % of GDP) of Natural Gas in 1992 to that in 1998?
Make the answer very short. 0.94. What is the ratio of the Mineral Rent(as % of GDP) in Oil in 1992 to that in 1998?
Your response must be concise. 2.09. What is the ratio of the Mineral Rent(as % of GDP) of Other Minerals in 1992 to that in 1998?
Your answer should be compact. 0.88. What is the ratio of the Mineral Rent(as % of GDP) of Coal in 1993 to that in 1994?
Keep it short and to the point. 0.64. What is the ratio of the Mineral Rent(as % of GDP) in Natural Gas in 1993 to that in 1994?
Ensure brevity in your answer.  1.22. What is the ratio of the Mineral Rent(as % of GDP) of Oil in 1993 to that in 1994?
Ensure brevity in your answer.  1.04. What is the ratio of the Mineral Rent(as % of GDP) in Other Minerals in 1993 to that in 1994?
Provide a short and direct response. 1.3. What is the ratio of the Mineral Rent(as % of GDP) of Coal in 1993 to that in 1995?
Offer a very short reply. 0.36. What is the ratio of the Mineral Rent(as % of GDP) of Natural Gas in 1993 to that in 1995?
Keep it short and to the point. 1.21. What is the ratio of the Mineral Rent(as % of GDP) in Oil in 1993 to that in 1995?
Your answer should be very brief. 0.97. What is the ratio of the Mineral Rent(as % of GDP) in Other Minerals in 1993 to that in 1995?
Your response must be concise. 1.31. What is the ratio of the Mineral Rent(as % of GDP) in Coal in 1993 to that in 1996?
Give a very brief answer. 0.42. What is the ratio of the Mineral Rent(as % of GDP) in Natural Gas in 1993 to that in 1996?
Offer a terse response. 0.9. What is the ratio of the Mineral Rent(as % of GDP) of Oil in 1993 to that in 1996?
Make the answer very short. 0.9. What is the ratio of the Mineral Rent(as % of GDP) of Other Minerals in 1993 to that in 1996?
Your answer should be very brief. 1.22. What is the ratio of the Mineral Rent(as % of GDP) in Coal in 1993 to that in 1997?
Offer a terse response. 0.5. What is the ratio of the Mineral Rent(as % of GDP) in Other Minerals in 1993 to that in 1997?
Your answer should be compact. 1.21. What is the ratio of the Mineral Rent(as % of GDP) in Coal in 1993 to that in 1998?
Ensure brevity in your answer.  1.26. What is the ratio of the Mineral Rent(as % of GDP) in Natural Gas in 1993 to that in 1998?
Offer a very short reply. 1.22. What is the ratio of the Mineral Rent(as % of GDP) in Oil in 1993 to that in 1998?
Ensure brevity in your answer.  1.84. What is the ratio of the Mineral Rent(as % of GDP) in Other Minerals in 1993 to that in 1998?
Your response must be concise. 0.73. What is the ratio of the Mineral Rent(as % of GDP) in Coal in 1994 to that in 1995?
Your response must be concise. 0.55. What is the ratio of the Mineral Rent(as % of GDP) in Oil in 1994 to that in 1995?
Provide a succinct answer. 0.93. What is the ratio of the Mineral Rent(as % of GDP) in Other Minerals in 1994 to that in 1995?
Offer a terse response. 1.01. What is the ratio of the Mineral Rent(as % of GDP) of Coal in 1994 to that in 1996?
Your answer should be very brief. 0.65. What is the ratio of the Mineral Rent(as % of GDP) of Natural Gas in 1994 to that in 1996?
Give a very brief answer. 0.74. What is the ratio of the Mineral Rent(as % of GDP) in Oil in 1994 to that in 1996?
Your answer should be compact. 0.87. What is the ratio of the Mineral Rent(as % of GDP) of Other Minerals in 1994 to that in 1996?
Keep it short and to the point. 0.94. What is the ratio of the Mineral Rent(as % of GDP) in Coal in 1994 to that in 1997?
Keep it short and to the point. 0.78. What is the ratio of the Mineral Rent(as % of GDP) in Natural Gas in 1994 to that in 1997?
Offer a terse response. 0.82. What is the ratio of the Mineral Rent(as % of GDP) in Oil in 1994 to that in 1997?
Your answer should be very brief. 0.96. What is the ratio of the Mineral Rent(as % of GDP) of Other Minerals in 1994 to that in 1997?
Your answer should be compact. 0.93. What is the ratio of the Mineral Rent(as % of GDP) of Coal in 1994 to that in 1998?
Your answer should be compact. 1.96. What is the ratio of the Mineral Rent(as % of GDP) of Natural Gas in 1994 to that in 1998?
Keep it short and to the point. 1.01. What is the ratio of the Mineral Rent(as % of GDP) in Oil in 1994 to that in 1998?
Make the answer very short. 1.77. What is the ratio of the Mineral Rent(as % of GDP) of Other Minerals in 1994 to that in 1998?
Your answer should be compact. 0.56. What is the ratio of the Mineral Rent(as % of GDP) of Coal in 1995 to that in 1996?
Keep it short and to the point. 1.17. What is the ratio of the Mineral Rent(as % of GDP) of Natural Gas in 1995 to that in 1996?
Ensure brevity in your answer.  0.75. What is the ratio of the Mineral Rent(as % of GDP) of Oil in 1995 to that in 1996?
Your answer should be very brief. 0.93. What is the ratio of the Mineral Rent(as % of GDP) of Other Minerals in 1995 to that in 1996?
Provide a succinct answer. 0.93. What is the ratio of the Mineral Rent(as % of GDP) of Coal in 1995 to that in 1997?
Offer a terse response. 1.4. What is the ratio of the Mineral Rent(as % of GDP) in Natural Gas in 1995 to that in 1997?
Offer a terse response. 0.82. What is the ratio of the Mineral Rent(as % of GDP) in Oil in 1995 to that in 1997?
Give a very brief answer. 1.03. What is the ratio of the Mineral Rent(as % of GDP) in Other Minerals in 1995 to that in 1997?
Give a very brief answer. 0.92. What is the ratio of the Mineral Rent(as % of GDP) of Coal in 1995 to that in 1998?
Make the answer very short. 3.54. What is the ratio of the Mineral Rent(as % of GDP) of Natural Gas in 1995 to that in 1998?
Provide a succinct answer. 1.01. What is the ratio of the Mineral Rent(as % of GDP) in Oil in 1995 to that in 1998?
Offer a very short reply. 1.9. What is the ratio of the Mineral Rent(as % of GDP) of Other Minerals in 1995 to that in 1998?
Provide a short and direct response. 0.56. What is the ratio of the Mineral Rent(as % of GDP) of Coal in 1996 to that in 1997?
Offer a very short reply. 1.2. What is the ratio of the Mineral Rent(as % of GDP) of Natural Gas in 1996 to that in 1997?
Keep it short and to the point. 1.1. What is the ratio of the Mineral Rent(as % of GDP) of Oil in 1996 to that in 1997?
Provide a succinct answer. 1.11. What is the ratio of the Mineral Rent(as % of GDP) in Other Minerals in 1996 to that in 1997?
Give a very brief answer. 0.99. What is the ratio of the Mineral Rent(as % of GDP) in Coal in 1996 to that in 1998?
Make the answer very short. 3.04. What is the ratio of the Mineral Rent(as % of GDP) in Natural Gas in 1996 to that in 1998?
Your response must be concise. 1.35. What is the ratio of the Mineral Rent(as % of GDP) of Oil in 1996 to that in 1998?
Give a very brief answer. 2.03. What is the ratio of the Mineral Rent(as % of GDP) in Other Minerals in 1996 to that in 1998?
Make the answer very short. 0.6. What is the ratio of the Mineral Rent(as % of GDP) of Coal in 1997 to that in 1998?
Your response must be concise. 2.52. What is the ratio of the Mineral Rent(as % of GDP) in Natural Gas in 1997 to that in 1998?
Provide a succinct answer. 1.23. What is the ratio of the Mineral Rent(as % of GDP) of Oil in 1997 to that in 1998?
Provide a short and direct response. 1.83. What is the ratio of the Mineral Rent(as % of GDP) in Other Minerals in 1997 to that in 1998?
Offer a terse response. 0.6. What is the difference between the highest and the second highest Mineral Rent(as % of GDP) in Coal?
Your answer should be very brief. 0. What is the difference between the highest and the second highest Mineral Rent(as % of GDP) of Natural Gas?
Your answer should be compact. 0.06. What is the difference between the highest and the second highest Mineral Rent(as % of GDP) of Oil?
Keep it short and to the point. 0.02. What is the difference between the highest and the second highest Mineral Rent(as % of GDP) in Other Minerals?
Your answer should be compact. 0.03. What is the difference between the highest and the lowest Mineral Rent(as % of GDP) in Coal?
Your answer should be compact. 0.27. What is the difference between the highest and the lowest Mineral Rent(as % of GDP) in Natural Gas?
Offer a very short reply. 0.19. What is the difference between the highest and the lowest Mineral Rent(as % of GDP) in Oil?
Your response must be concise. 0.44. What is the difference between the highest and the lowest Mineral Rent(as % of GDP) in Other Minerals?
Your response must be concise. 0.12. 